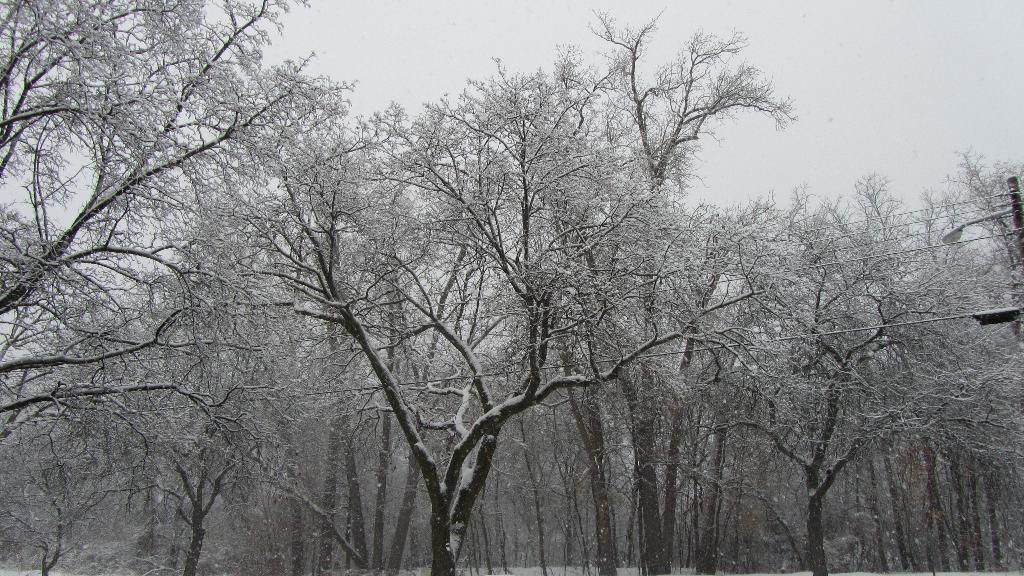Please provide a concise description of this image. This image consists of trees in the middle. There is sky at the top. There is ice in this image. 